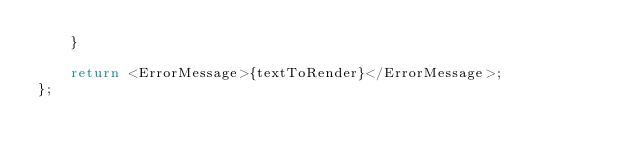<code> <loc_0><loc_0><loc_500><loc_500><_TypeScript_>    }

    return <ErrorMessage>{textToRender}</ErrorMessage>;
};
</code> 